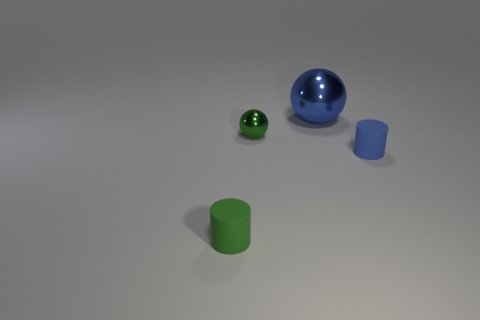Add 3 green shiny objects. How many objects exist? 7 Subtract all blue metallic cubes. Subtract all green balls. How many objects are left? 3 Add 3 blue spheres. How many blue spheres are left? 4 Add 1 big red shiny cylinders. How many big red shiny cylinders exist? 1 Subtract 0 cyan cylinders. How many objects are left? 4 